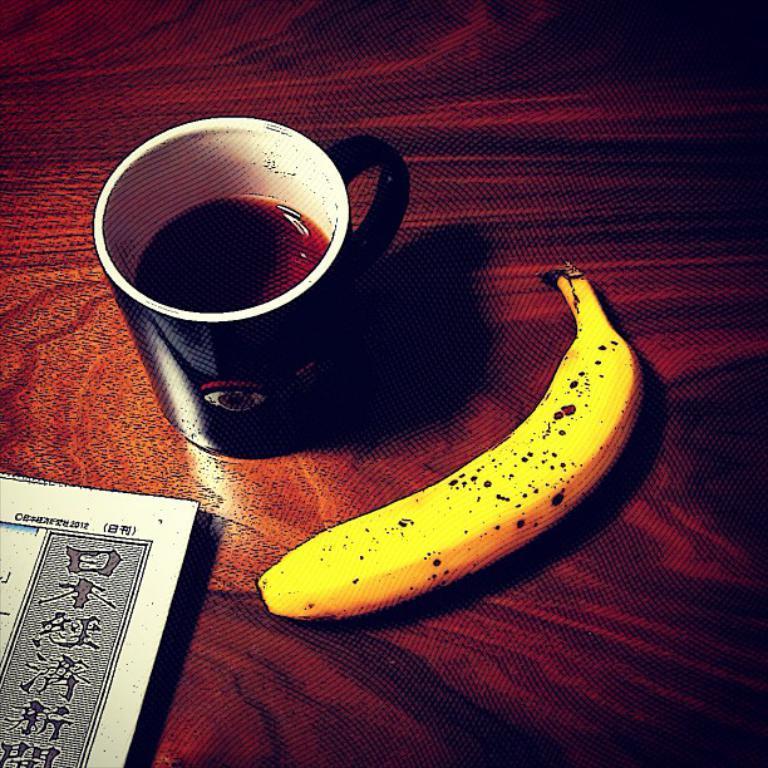Describe this image in one or two sentences. In this image, we can see a liquid in a cup, banana and paper on the wooden surface. 